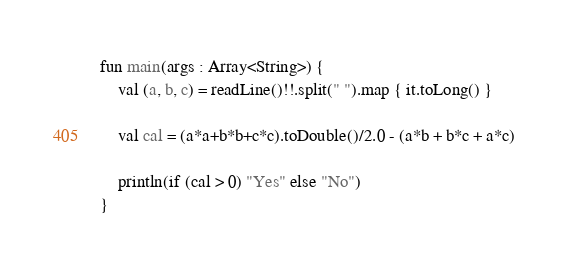Convert code to text. <code><loc_0><loc_0><loc_500><loc_500><_Kotlin_>fun main(args : Array<String>) {
    val (a, b, c) = readLine()!!.split(" ").map { it.toLong() }

    val cal = (a*a+b*b+c*c).toDouble()/2.0 - (a*b + b*c + a*c)

    println(if (cal > 0) "Yes" else "No")
}</code> 